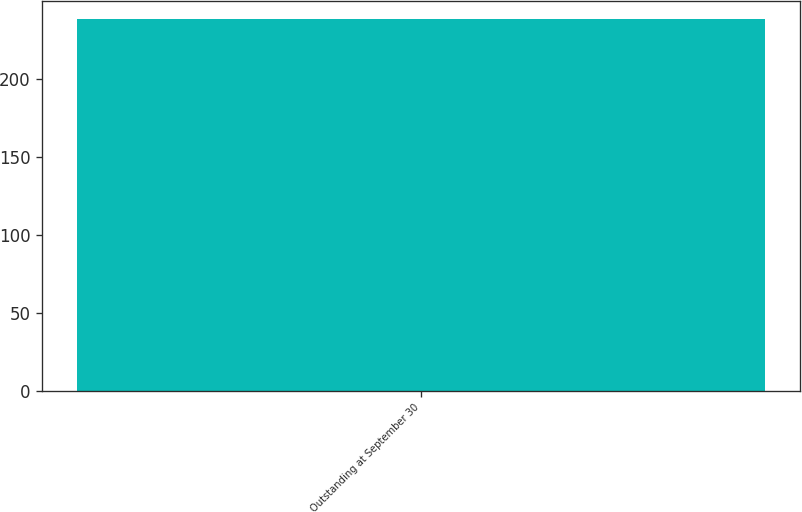Convert chart. <chart><loc_0><loc_0><loc_500><loc_500><bar_chart><fcel>Outstanding at September 30<nl><fcel>238<nl></chart> 